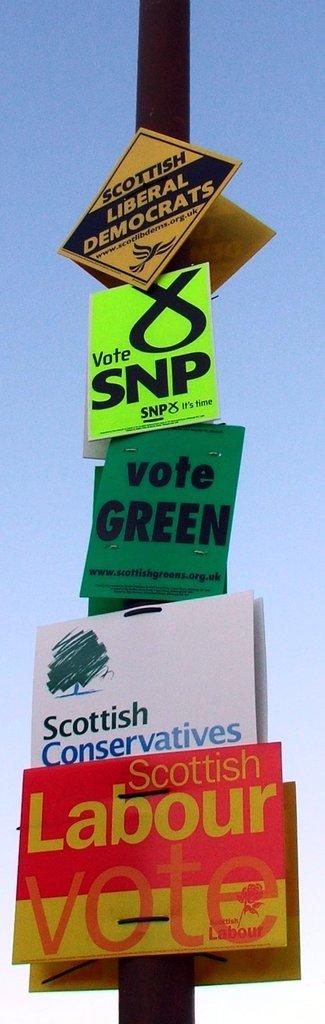What does the red sign read?
Your answer should be compact. Scottish labour vote. What does the green page want you to vote for?
Ensure brevity in your answer.  Green. 